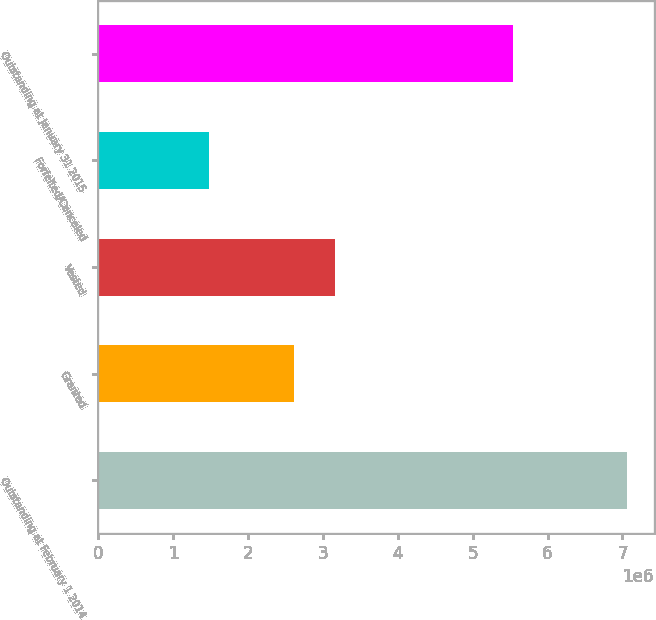Convert chart to OTSL. <chart><loc_0><loc_0><loc_500><loc_500><bar_chart><fcel>Outstanding at February 1 2014<fcel>Granted<fcel>Vested<fcel>Forfeited/Canceled<fcel>Outstanding at January 31 2015<nl><fcel>7.065e+06<fcel>2.609e+06<fcel>3.1681e+06<fcel>1.474e+06<fcel>5.543e+06<nl></chart> 